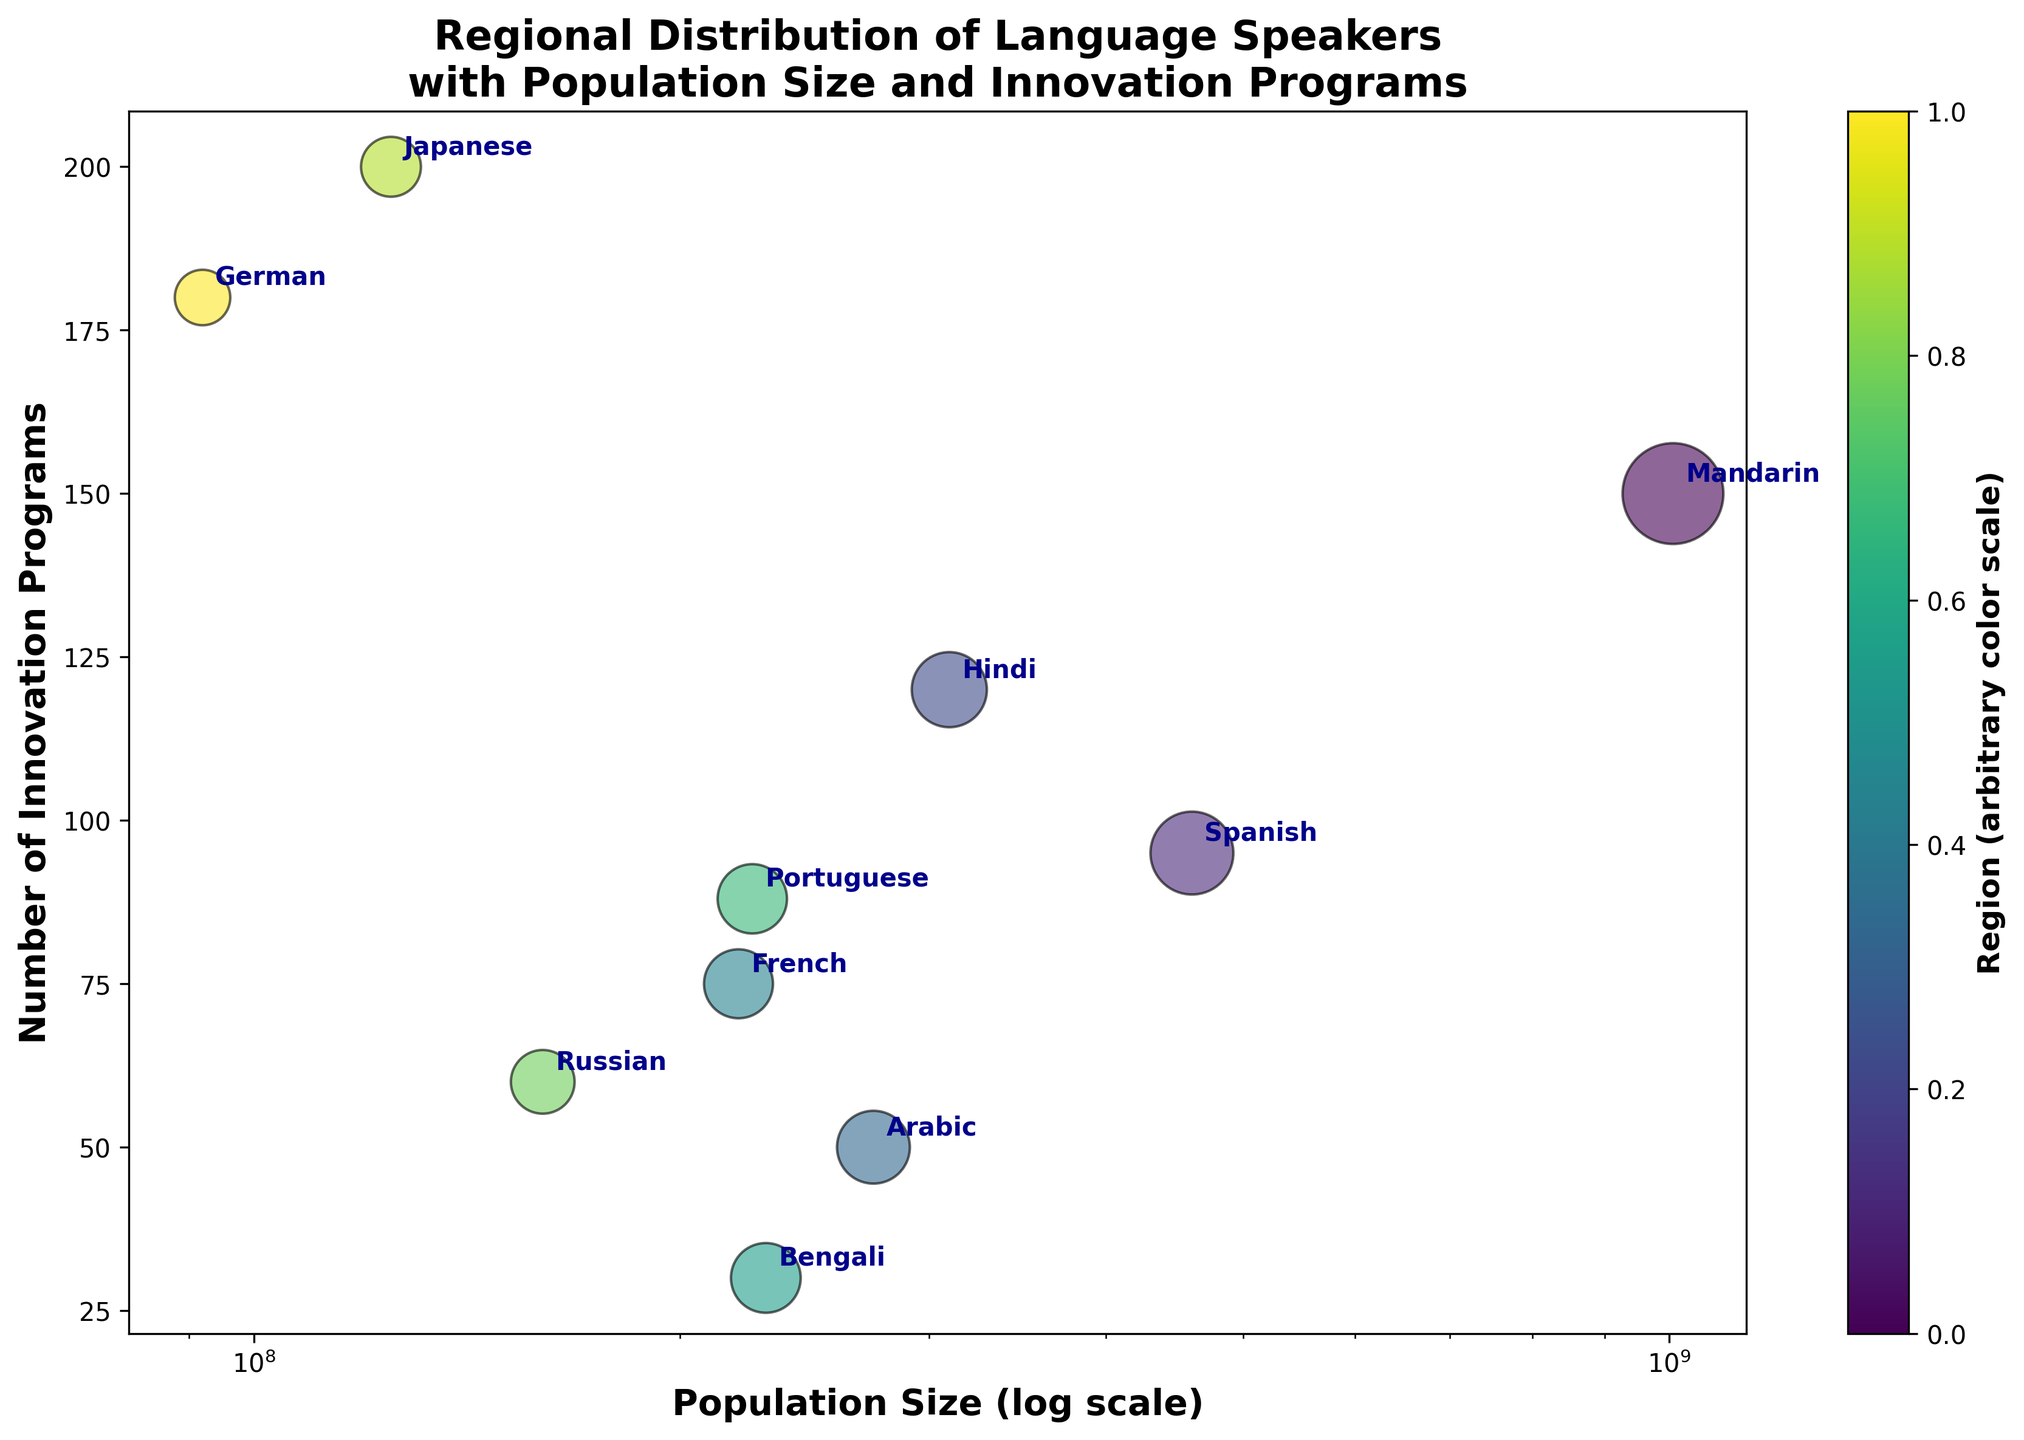What is the title of the figure? The title is usually positioned at the top of the figure and gives a summary of what the figure represents. The title of this figure is "Regional Distribution of Language Speakers with Population Size and Innovation Programs".
Answer: Regional Distribution of Language Speakers with Population Size and Innovation Programs Which language has the largest population size? To find the language with the largest population size, look for the largest circle and check the label. The language with the largest circle is Mandarin.
Answer: Mandarin Which region has the highest number of innovation programs? The highest vertical position of a bubble indicates the highest number of innovation programs. The bubble located at the highest point on the vertical axis represents Japanese, which is from East Asia.
Answer: East Asia How does the population size of Spanish compare to the population size of German? The size of the bubble indicates the population size. The Spanish bubble is much larger than the German bubble, indicating that Spanish has a larger population size compared to German.
Answer: Spanish > German Which language has the smallest number of innovation programs? The smallest vertical position on the y-axis represents the fewest innovation programs. The bubble at the lowest point on the y-axis is Bengali.
Answer: Bengali Among the languages in South Asia, which one has a larger population, Hindi or Bengali? To compare Hindi and Bengali, look at the sizes of their bubbles. The circle representing Hindi is larger than that of Bengali. Therefore, Hindi has a larger population size.
Answer: Hindi What is the relationship between population size and the number of innovation programs? To understand this, observe the overall trend of the bubbles. There seems to be a mixed pattern where languages with both large and small populations have varying numbers of innovation programs.
Answer: Mixed pattern Compare the number of innovation programs between Arabic and French. Which one has more? Look at the vertical positions of the Arabic and French bubbles. The French bubble is higher than the Arabic bubble on the y-axis, meaning French has more innovation programs.
Answer: French What is the color scale used in the figure? The color scale represents different regions, as denoted on the color bar on the right side of the figure. Each color corresponds to a different region.
Answer: Different regions How many languages are represented in the bubble chart? Count the number of labeled bubbles in the figure. Each label corresponds to a language. There are 10 bubbles, each representing a different language.
Answer: 10 